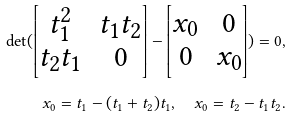Convert formula to latex. <formula><loc_0><loc_0><loc_500><loc_500>\det ( \begin{bmatrix} t _ { 1 } ^ { 2 } & t _ { 1 } t _ { 2 } \\ t _ { 2 } t _ { 1 } & 0 \end{bmatrix} - \begin{bmatrix} x _ { 0 } & 0 \\ 0 & x _ { 0 } \end{bmatrix} ) = 0 , \\ x _ { 0 } = t _ { 1 } - ( t _ { 1 } + t _ { 2 } ) t _ { 1 } , \quad x _ { 0 } = t _ { 2 } - t _ { 1 } t _ { 2 } .</formula> 